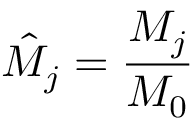Convert formula to latex. <formula><loc_0><loc_0><loc_500><loc_500>\hat { M } _ { j } = \frac { M _ { j } } { M _ { 0 } }</formula> 